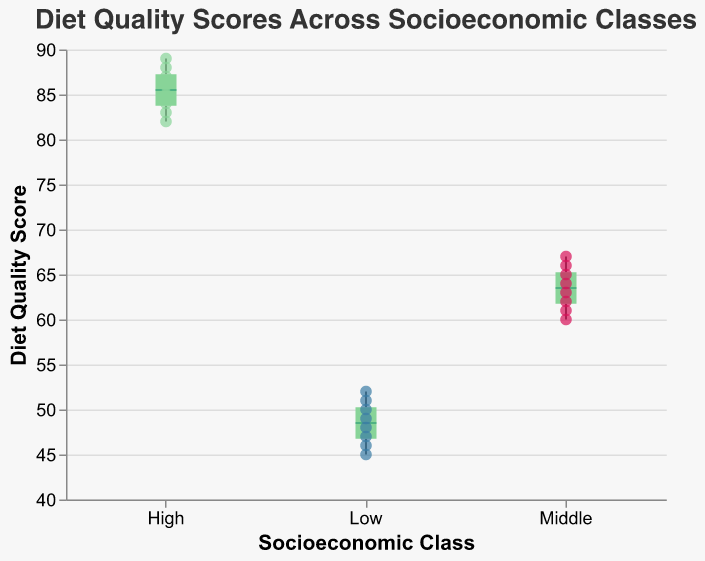what is the median Diet Quality Score for the Middle socioeconomic class? The median is represented graphically by the line within each box in the box plot. For the Middle socioeconomic class, this line intersects a mark around the 63
Answer: 63 Which Socioeconomic Class has the highest Diet Quality Scores range? To check the range, we look for the class with the largest distance between its minimum and maximum values in the box plot. The High class spans from 82 to 89, the largest extent
Answer: High How many individuals are from the Low socioeconomic class? Count the scatter points in the Low box, representing individual scores. There are 8 scatter points for the Low Socioeconomic Class
Answer: 8 What is the range of Diet Quality Scores for the High socioeconomic class? The range is determined by subtracting the minimum value from the maximum within the whiskers. The High class ranges from 89 (max) to 82 (min), resulting in a range of 89-82=7
Answer: 7 Which individual has the highest Diet Quality Score in the High Socioeconomic Class? The scatter point furthest up within the High class points to the individual with the maximum score. Hovering over it reveals Anna, with a score of 89
Answer: Anna What is the interquartile range (IQR) for the Low socioeconomic class? The IQR is the difference between the third quartile (75th percentile) and the first quartile (25th percentile). For the Low class, the box edges imply an IQR around 46 to 50.5; thus, IQR is approximately 4.5
Answer: 4.5 Compare the Diet Quality Scores of the highest individual in the Low and High socioeconomic classes. Within the Low class, the highest point (Kate) has 52, while the High class's highest point (Anna) has 89. The difference in scores is 89-52 = 37
Answer: High class by 37 points What is the median Diet Quality Score for the High socioeconomic class? Identify the line within the box for High - intersects at around 85.5
Answer: 85.5 What is the range of the Middle group's Diet Quality Scores? The difference between max (67) and min (60) values in Middle group gives us 67-60 = 7
Answer: 7 